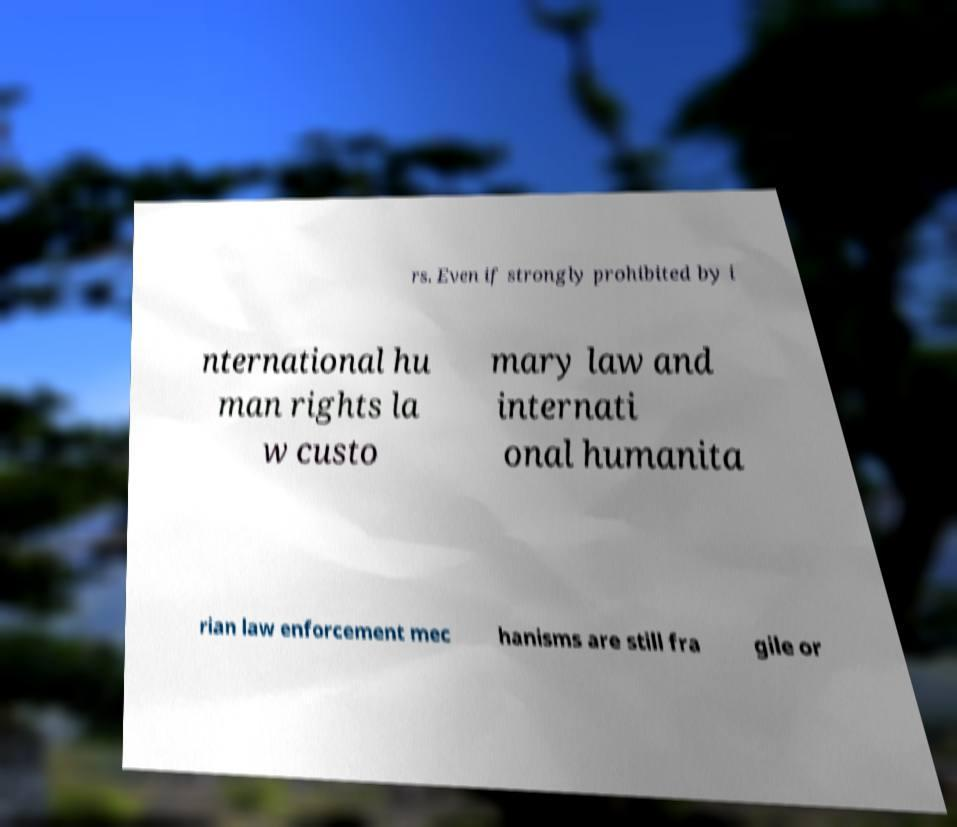I need the written content from this picture converted into text. Can you do that? rs. Even if strongly prohibited by i nternational hu man rights la w custo mary law and internati onal humanita rian law enforcement mec hanisms are still fra gile or 